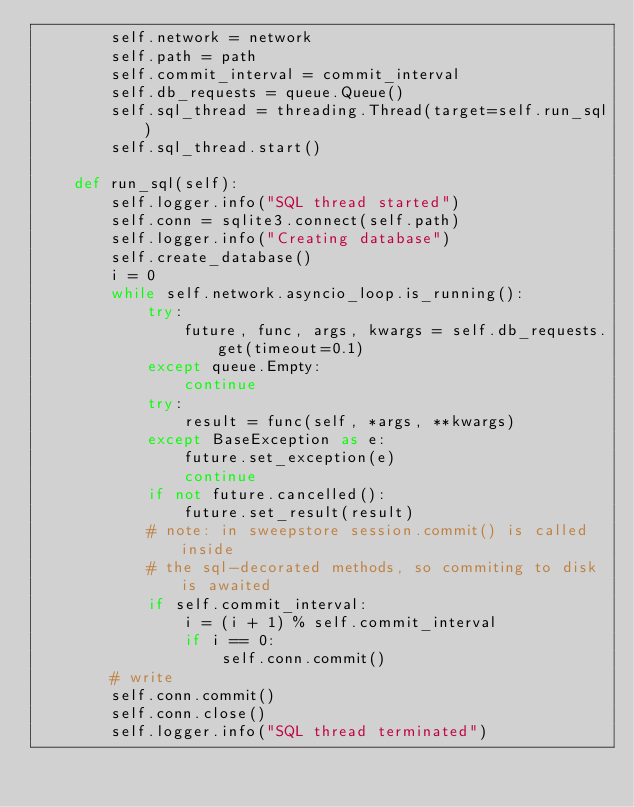<code> <loc_0><loc_0><loc_500><loc_500><_Python_>        self.network = network
        self.path = path
        self.commit_interval = commit_interval
        self.db_requests = queue.Queue()
        self.sql_thread = threading.Thread(target=self.run_sql)
        self.sql_thread.start()

    def run_sql(self):
        self.logger.info("SQL thread started")
        self.conn = sqlite3.connect(self.path)
        self.logger.info("Creating database")
        self.create_database()
        i = 0
        while self.network.asyncio_loop.is_running():
            try:
                future, func, args, kwargs = self.db_requests.get(timeout=0.1)
            except queue.Empty:
                continue
            try:
                result = func(self, *args, **kwargs)
            except BaseException as e:
                future.set_exception(e)
                continue
            if not future.cancelled():
                future.set_result(result)
            # note: in sweepstore session.commit() is called inside
            # the sql-decorated methods, so commiting to disk is awaited
            if self.commit_interval:
                i = (i + 1) % self.commit_interval
                if i == 0:
                    self.conn.commit()
        # write
        self.conn.commit()
        self.conn.close()
        self.logger.info("SQL thread terminated")
</code> 